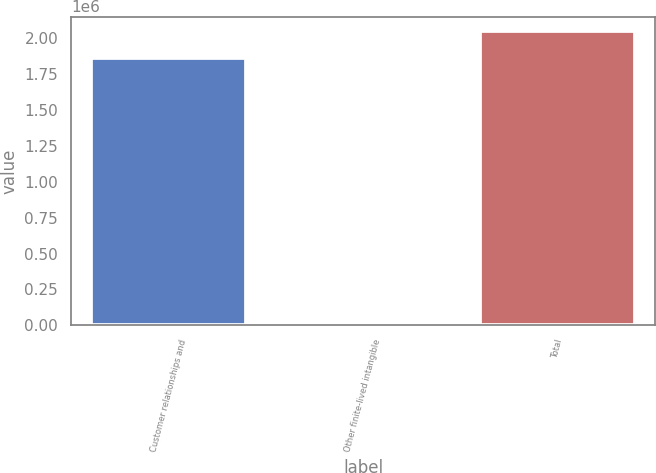<chart> <loc_0><loc_0><loc_500><loc_500><bar_chart><fcel>Customer relationships and<fcel>Other finite-lived intangible<fcel>Total<nl><fcel>1.86345e+06<fcel>20929<fcel>2.04979e+06<nl></chart> 